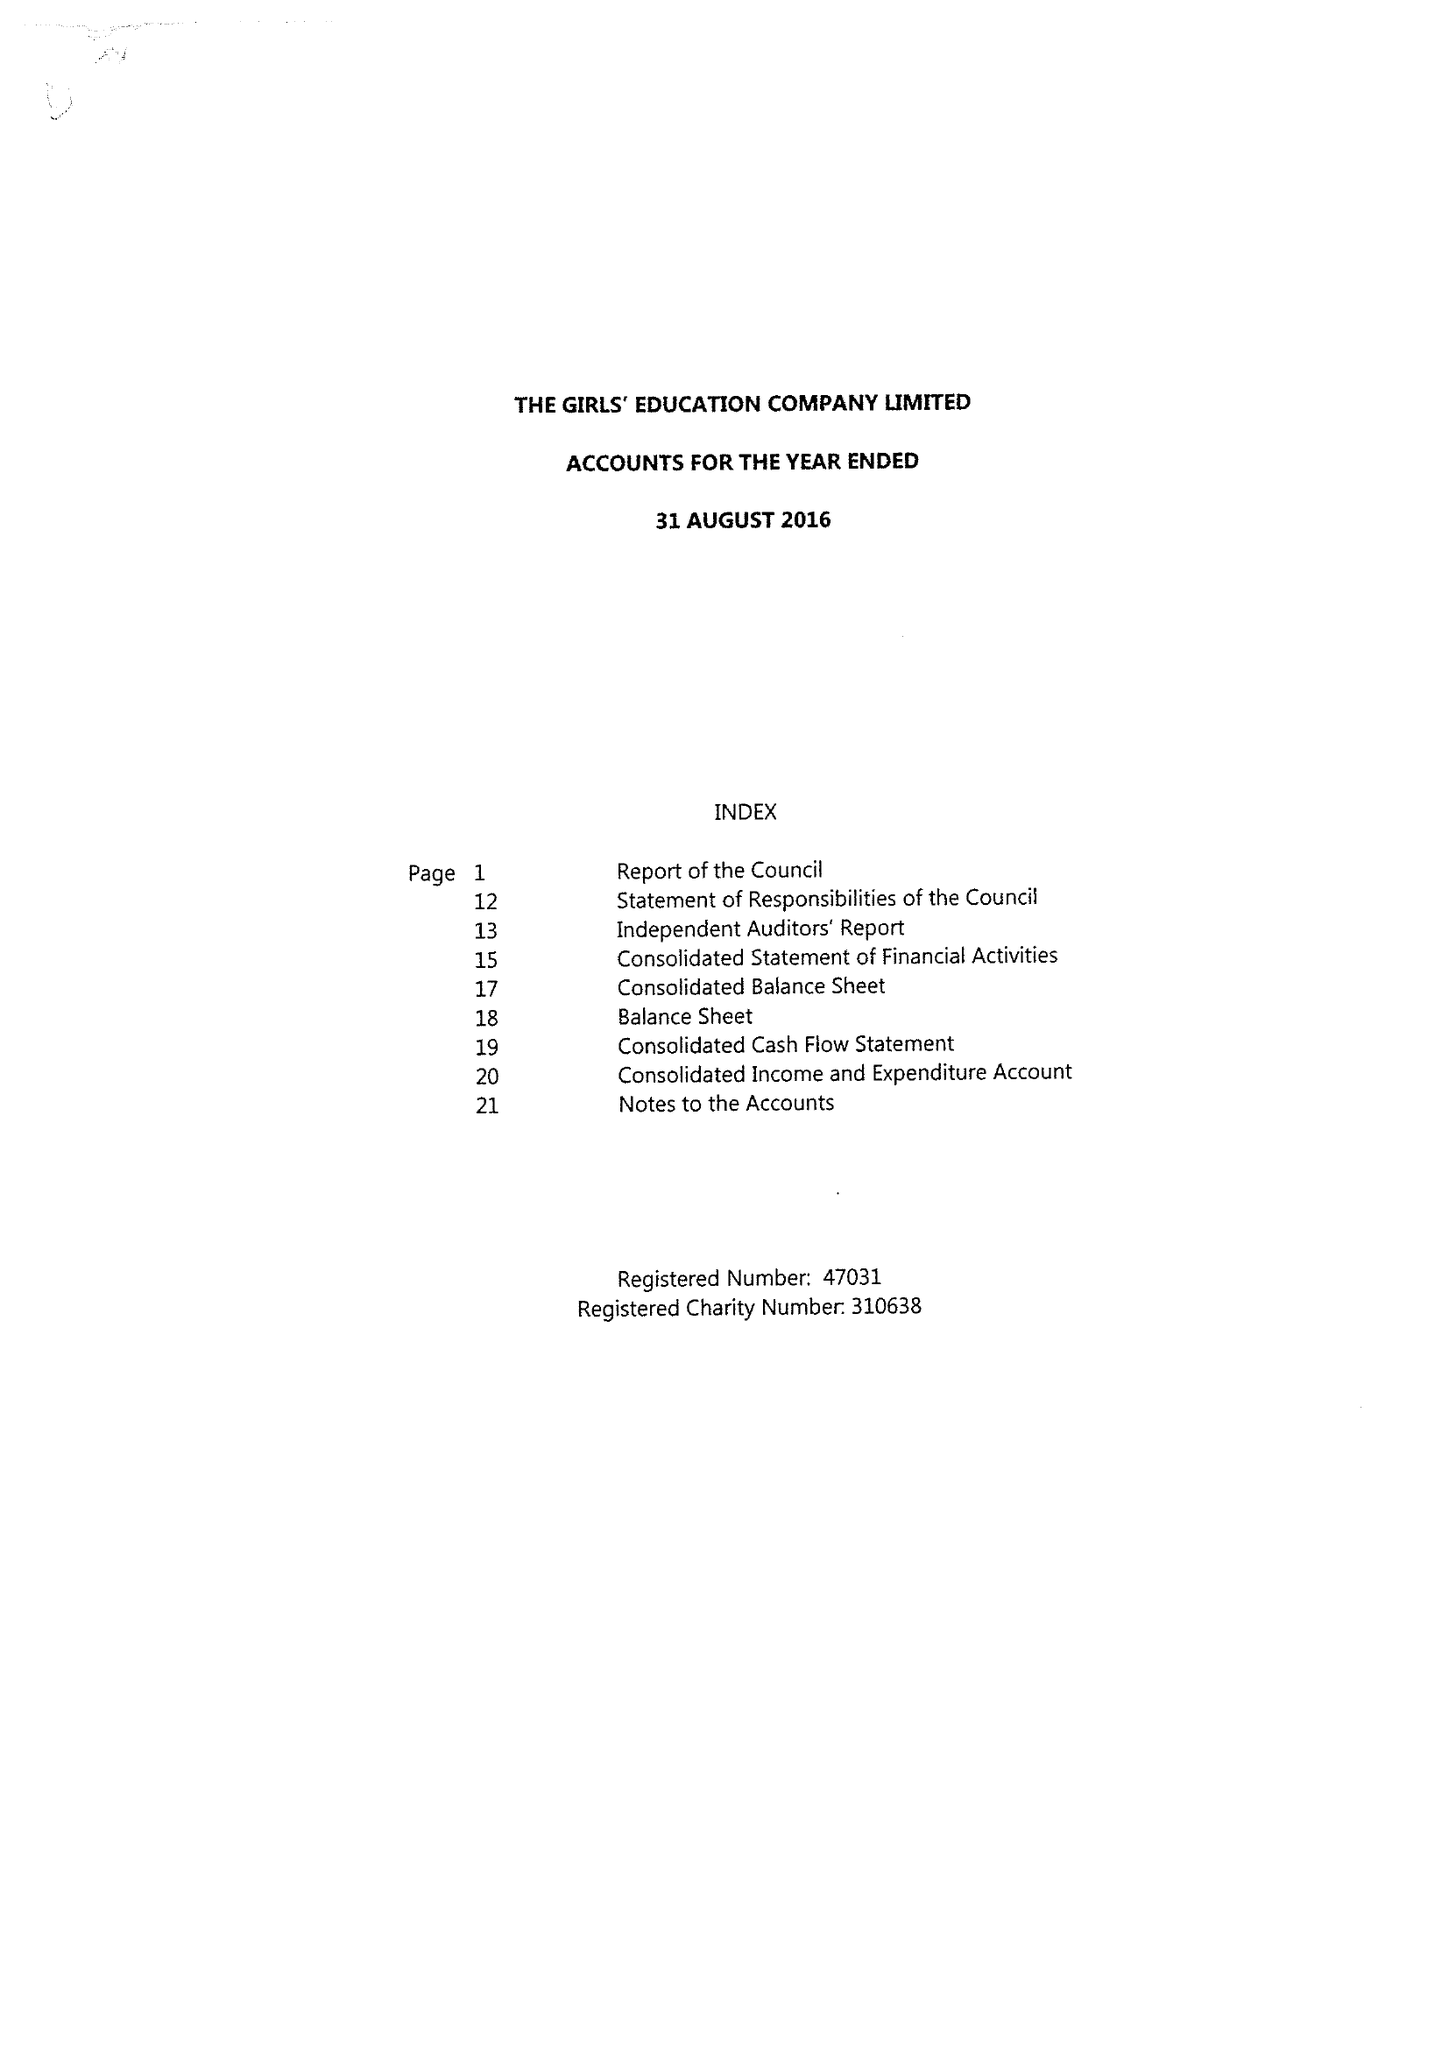What is the value for the address__postcode?
Answer the question using a single word or phrase. HP11 1PE 